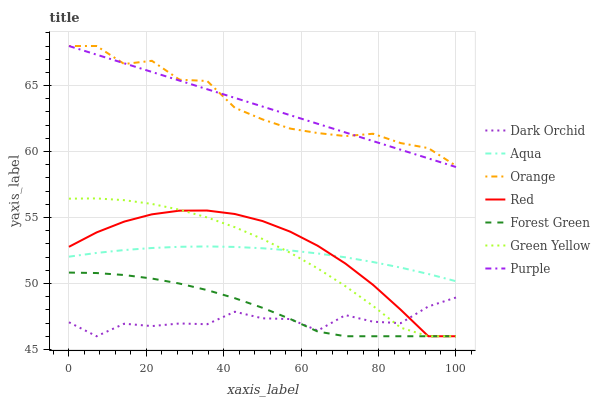Does Dark Orchid have the minimum area under the curve?
Answer yes or no. Yes. Does Orange have the maximum area under the curve?
Answer yes or no. Yes. Does Aqua have the minimum area under the curve?
Answer yes or no. No. Does Aqua have the maximum area under the curve?
Answer yes or no. No. Is Purple the smoothest?
Answer yes or no. Yes. Is Dark Orchid the roughest?
Answer yes or no. Yes. Is Aqua the smoothest?
Answer yes or no. No. Is Aqua the roughest?
Answer yes or no. No. Does Aqua have the lowest value?
Answer yes or no. No. Does Orange have the highest value?
Answer yes or no. Yes. Does Aqua have the highest value?
Answer yes or no. No. Is Forest Green less than Orange?
Answer yes or no. Yes. Is Purple greater than Forest Green?
Answer yes or no. Yes. Does Green Yellow intersect Aqua?
Answer yes or no. Yes. Is Green Yellow less than Aqua?
Answer yes or no. No. Is Green Yellow greater than Aqua?
Answer yes or no. No. Does Forest Green intersect Orange?
Answer yes or no. No. 